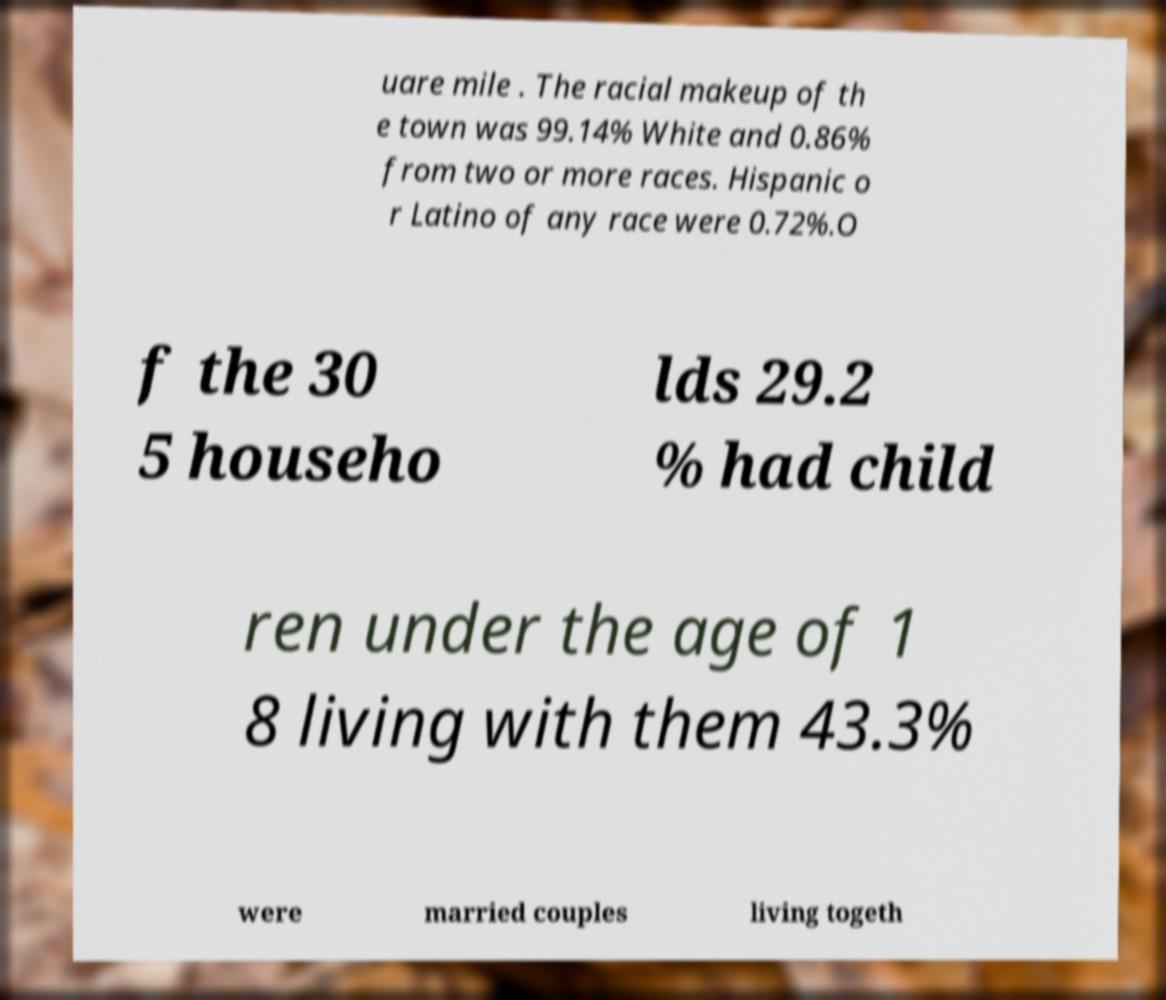For documentation purposes, I need the text within this image transcribed. Could you provide that? uare mile . The racial makeup of th e town was 99.14% White and 0.86% from two or more races. Hispanic o r Latino of any race were 0.72%.O f the 30 5 househo lds 29.2 % had child ren under the age of 1 8 living with them 43.3% were married couples living togeth 